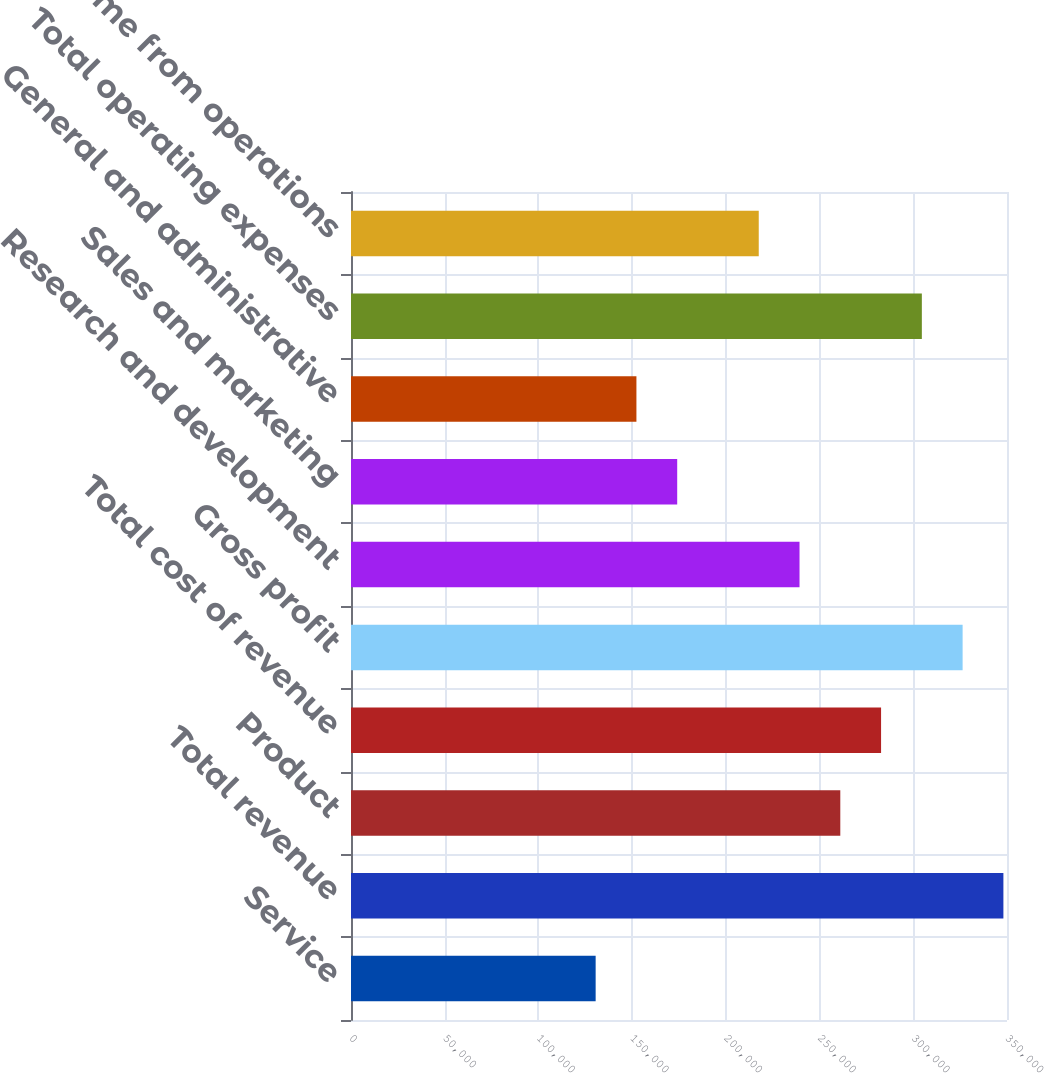<chart> <loc_0><loc_0><loc_500><loc_500><bar_chart><fcel>Service<fcel>Total revenue<fcel>Product<fcel>Total cost of revenue<fcel>Gross profit<fcel>Research and development<fcel>Sales and marketing<fcel>General and administrative<fcel>Total operating expenses<fcel>Income from operations<nl><fcel>130529<fcel>348077<fcel>261058<fcel>282812<fcel>326322<fcel>239303<fcel>174038<fcel>152284<fcel>304567<fcel>217548<nl></chart> 